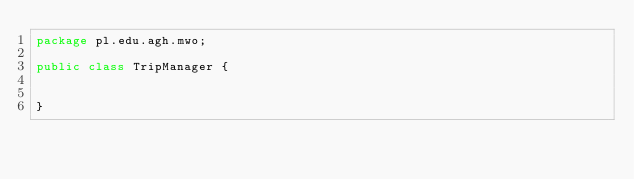<code> <loc_0><loc_0><loc_500><loc_500><_Java_>package pl.edu.agh.mwo;

public class TripManager {


}
</code> 